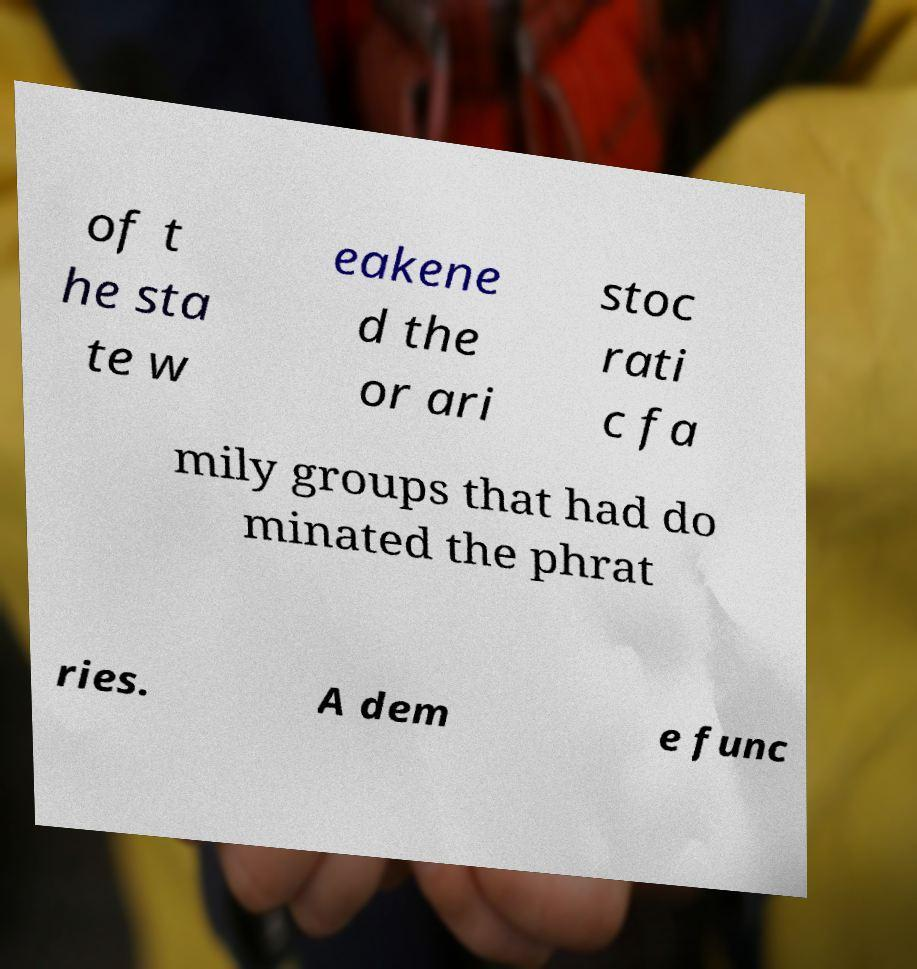Can you read and provide the text displayed in the image?This photo seems to have some interesting text. Can you extract and type it out for me? of t he sta te w eakene d the or ari stoc rati c fa mily groups that had do minated the phrat ries. A dem e func 